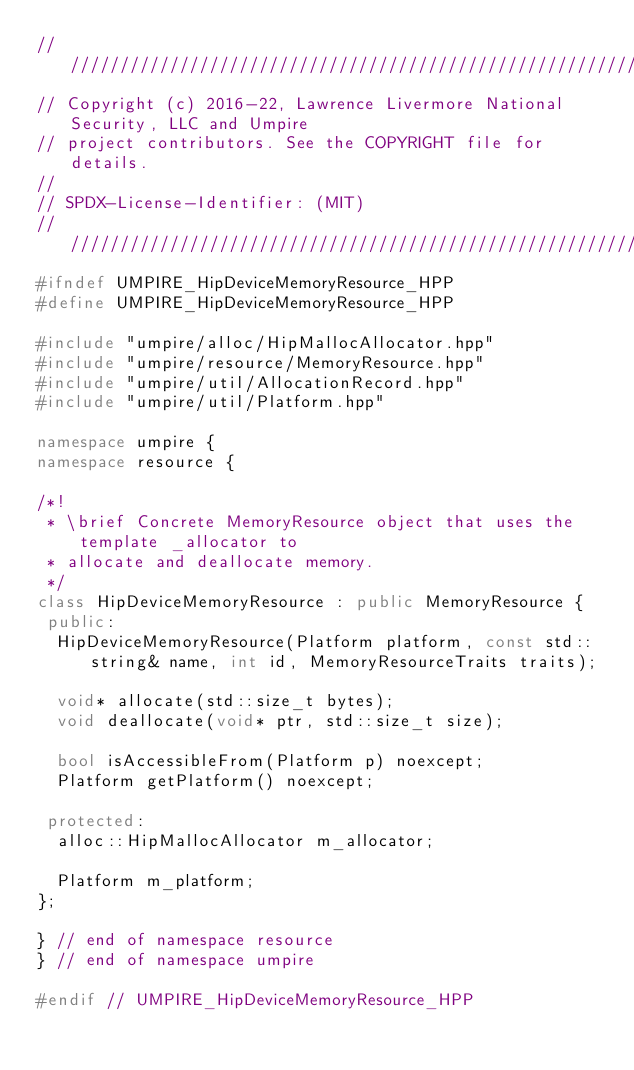<code> <loc_0><loc_0><loc_500><loc_500><_C++_>//////////////////////////////////////////////////////////////////////////////
// Copyright (c) 2016-22, Lawrence Livermore National Security, LLC and Umpire
// project contributors. See the COPYRIGHT file for details.
//
// SPDX-License-Identifier: (MIT)
//////////////////////////////////////////////////////////////////////////////
#ifndef UMPIRE_HipDeviceMemoryResource_HPP
#define UMPIRE_HipDeviceMemoryResource_HPP

#include "umpire/alloc/HipMallocAllocator.hpp"
#include "umpire/resource/MemoryResource.hpp"
#include "umpire/util/AllocationRecord.hpp"
#include "umpire/util/Platform.hpp"

namespace umpire {
namespace resource {

/*!
 * \brief Concrete MemoryResource object that uses the template _allocator to
 * allocate and deallocate memory.
 */
class HipDeviceMemoryResource : public MemoryResource {
 public:
  HipDeviceMemoryResource(Platform platform, const std::string& name, int id, MemoryResourceTraits traits);

  void* allocate(std::size_t bytes);
  void deallocate(void* ptr, std::size_t size);

  bool isAccessibleFrom(Platform p) noexcept;
  Platform getPlatform() noexcept;

 protected:
  alloc::HipMallocAllocator m_allocator;

  Platform m_platform;
};

} // end of namespace resource
} // end of namespace umpire

#endif // UMPIRE_HipDeviceMemoryResource_HPP
</code> 